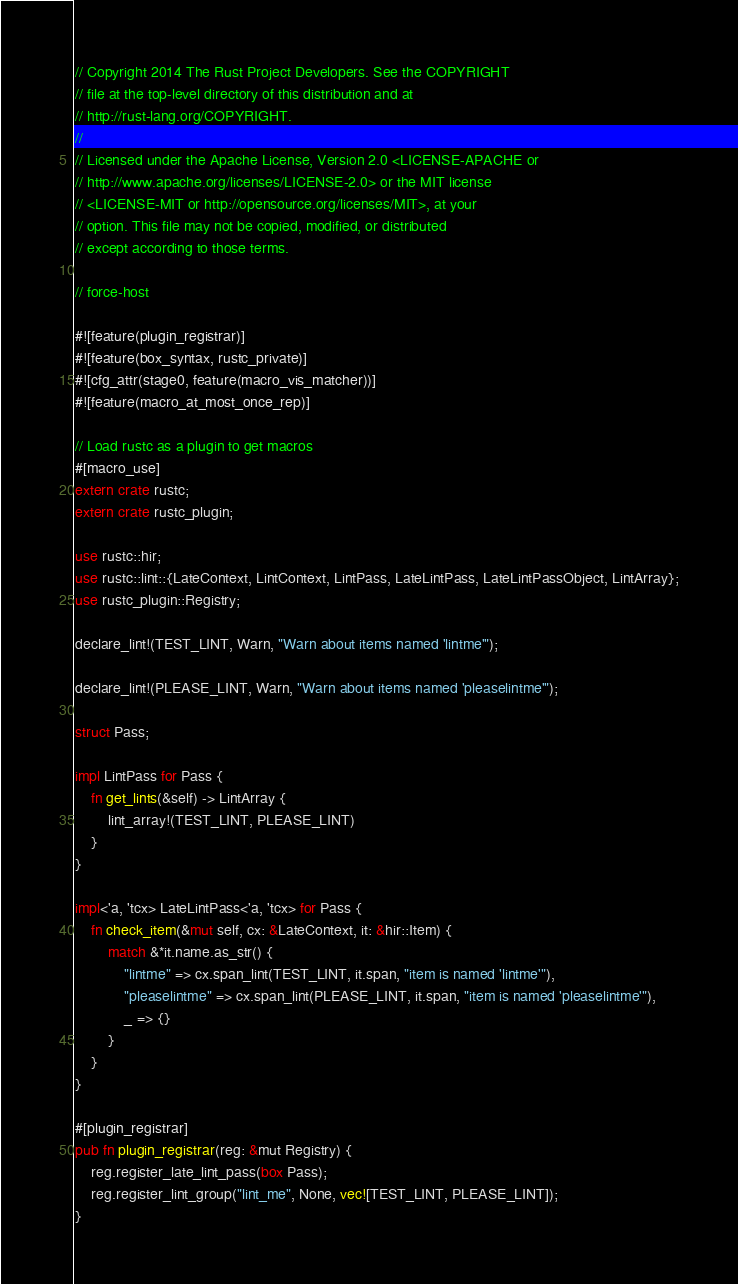<code> <loc_0><loc_0><loc_500><loc_500><_Rust_>// Copyright 2014 The Rust Project Developers. See the COPYRIGHT
// file at the top-level directory of this distribution and at
// http://rust-lang.org/COPYRIGHT.
//
// Licensed under the Apache License, Version 2.0 <LICENSE-APACHE or
// http://www.apache.org/licenses/LICENSE-2.0> or the MIT license
// <LICENSE-MIT or http://opensource.org/licenses/MIT>, at your
// option. This file may not be copied, modified, or distributed
// except according to those terms.

// force-host

#![feature(plugin_registrar)]
#![feature(box_syntax, rustc_private)]
#![cfg_attr(stage0, feature(macro_vis_matcher))]
#![feature(macro_at_most_once_rep)]

// Load rustc as a plugin to get macros
#[macro_use]
extern crate rustc;
extern crate rustc_plugin;

use rustc::hir;
use rustc::lint::{LateContext, LintContext, LintPass, LateLintPass, LateLintPassObject, LintArray};
use rustc_plugin::Registry;

declare_lint!(TEST_LINT, Warn, "Warn about items named 'lintme'");

declare_lint!(PLEASE_LINT, Warn, "Warn about items named 'pleaselintme'");

struct Pass;

impl LintPass for Pass {
    fn get_lints(&self) -> LintArray {
        lint_array!(TEST_LINT, PLEASE_LINT)
    }
}

impl<'a, 'tcx> LateLintPass<'a, 'tcx> for Pass {
    fn check_item(&mut self, cx: &LateContext, it: &hir::Item) {
        match &*it.name.as_str() {
            "lintme" => cx.span_lint(TEST_LINT, it.span, "item is named 'lintme'"),
            "pleaselintme" => cx.span_lint(PLEASE_LINT, it.span, "item is named 'pleaselintme'"),
            _ => {}
        }
    }
}

#[plugin_registrar]
pub fn plugin_registrar(reg: &mut Registry) {
    reg.register_late_lint_pass(box Pass);
    reg.register_lint_group("lint_me", None, vec![TEST_LINT, PLEASE_LINT]);
}
</code> 